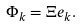<formula> <loc_0><loc_0><loc_500><loc_500>\Phi _ { k } = \Xi e _ { k } .</formula> 